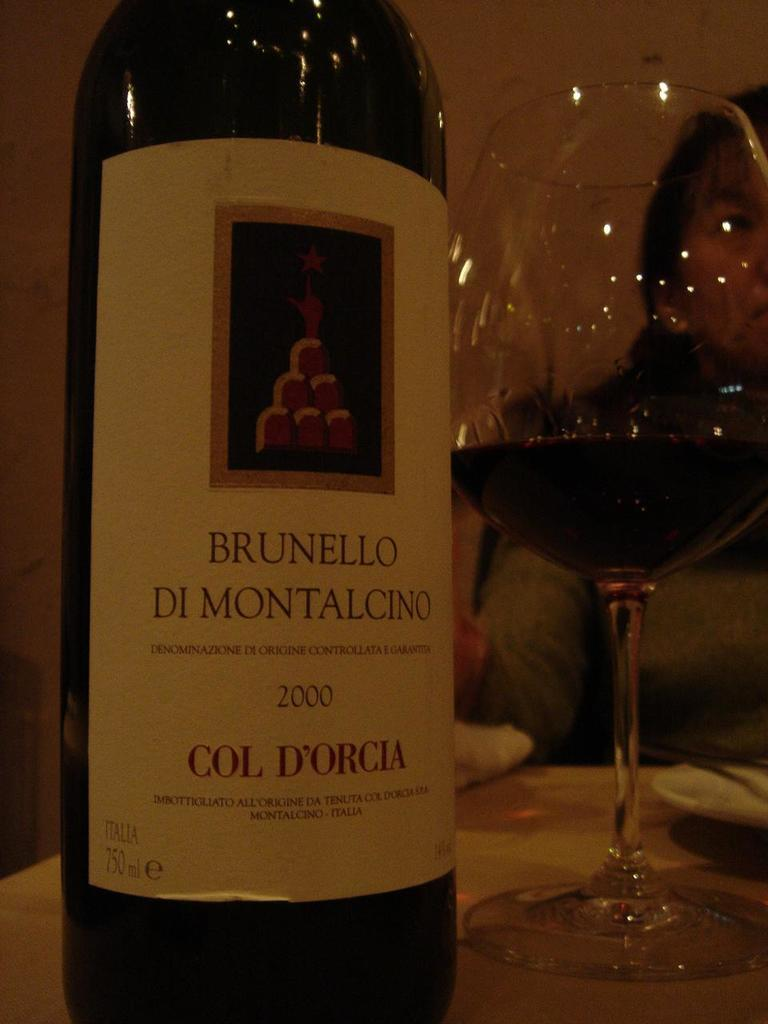What can be seen in the image that is used for holding liquids? There is a bottle and a glass with a drink in the image. What type of drink might be in the glass? The specific type of drink cannot be determined from the image. Can you describe the woman in the background of the image? The facts provided do not give any details about the woman in the background. What type of copper material is present in the image? There is no copper material present in the image. How does the woman in the background express her hate towards the drink in the glass? The facts provided do not mention any emotions or expressions of the woman in the background. 